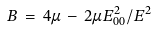Convert formula to latex. <formula><loc_0><loc_0><loc_500><loc_500>B \, = \, 4 \mu \, - \, 2 \mu E _ { 0 0 } ^ { 2 } / E ^ { 2 }</formula> 